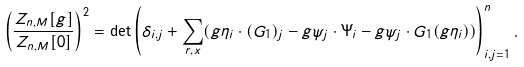Convert formula to latex. <formula><loc_0><loc_0><loc_500><loc_500>\left ( \frac { Z _ { n , M } [ g ] } { Z _ { n , M } [ 0 ] } \right ) ^ { 2 } = \det \left ( \delta _ { i , j } + \sum _ { r , x } ( g \eta _ { i } \cdot ( G _ { 1 } ) _ { j } - g \psi _ { j } \cdot \Psi _ { i } - g \psi _ { j } \cdot G _ { 1 } ( g \eta _ { i } ) ) \right ) _ { i , j = 1 } ^ { n } .</formula> 